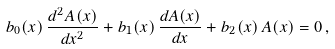<formula> <loc_0><loc_0><loc_500><loc_500>b _ { 0 } ( x ) \, \frac { d ^ { 2 } A ( x ) } { d x ^ { 2 } } + b _ { 1 } ( x ) \, \frac { d A ( x ) } { d x } + b _ { 2 } ( x ) \, A ( x ) = 0 \, ,</formula> 